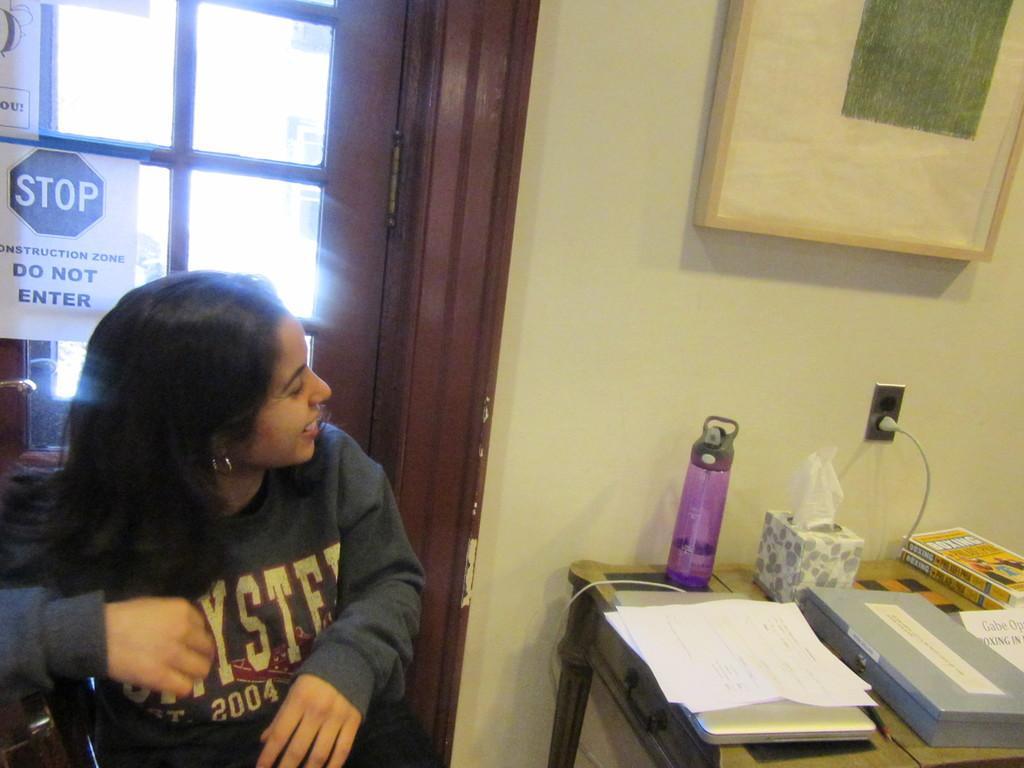Describe this image in one or two sentences. In the image there is a woman sat at the left side corner and in front of her there is table with books,bottle on it and on right side wall there is photo frame , backside of her its door. 